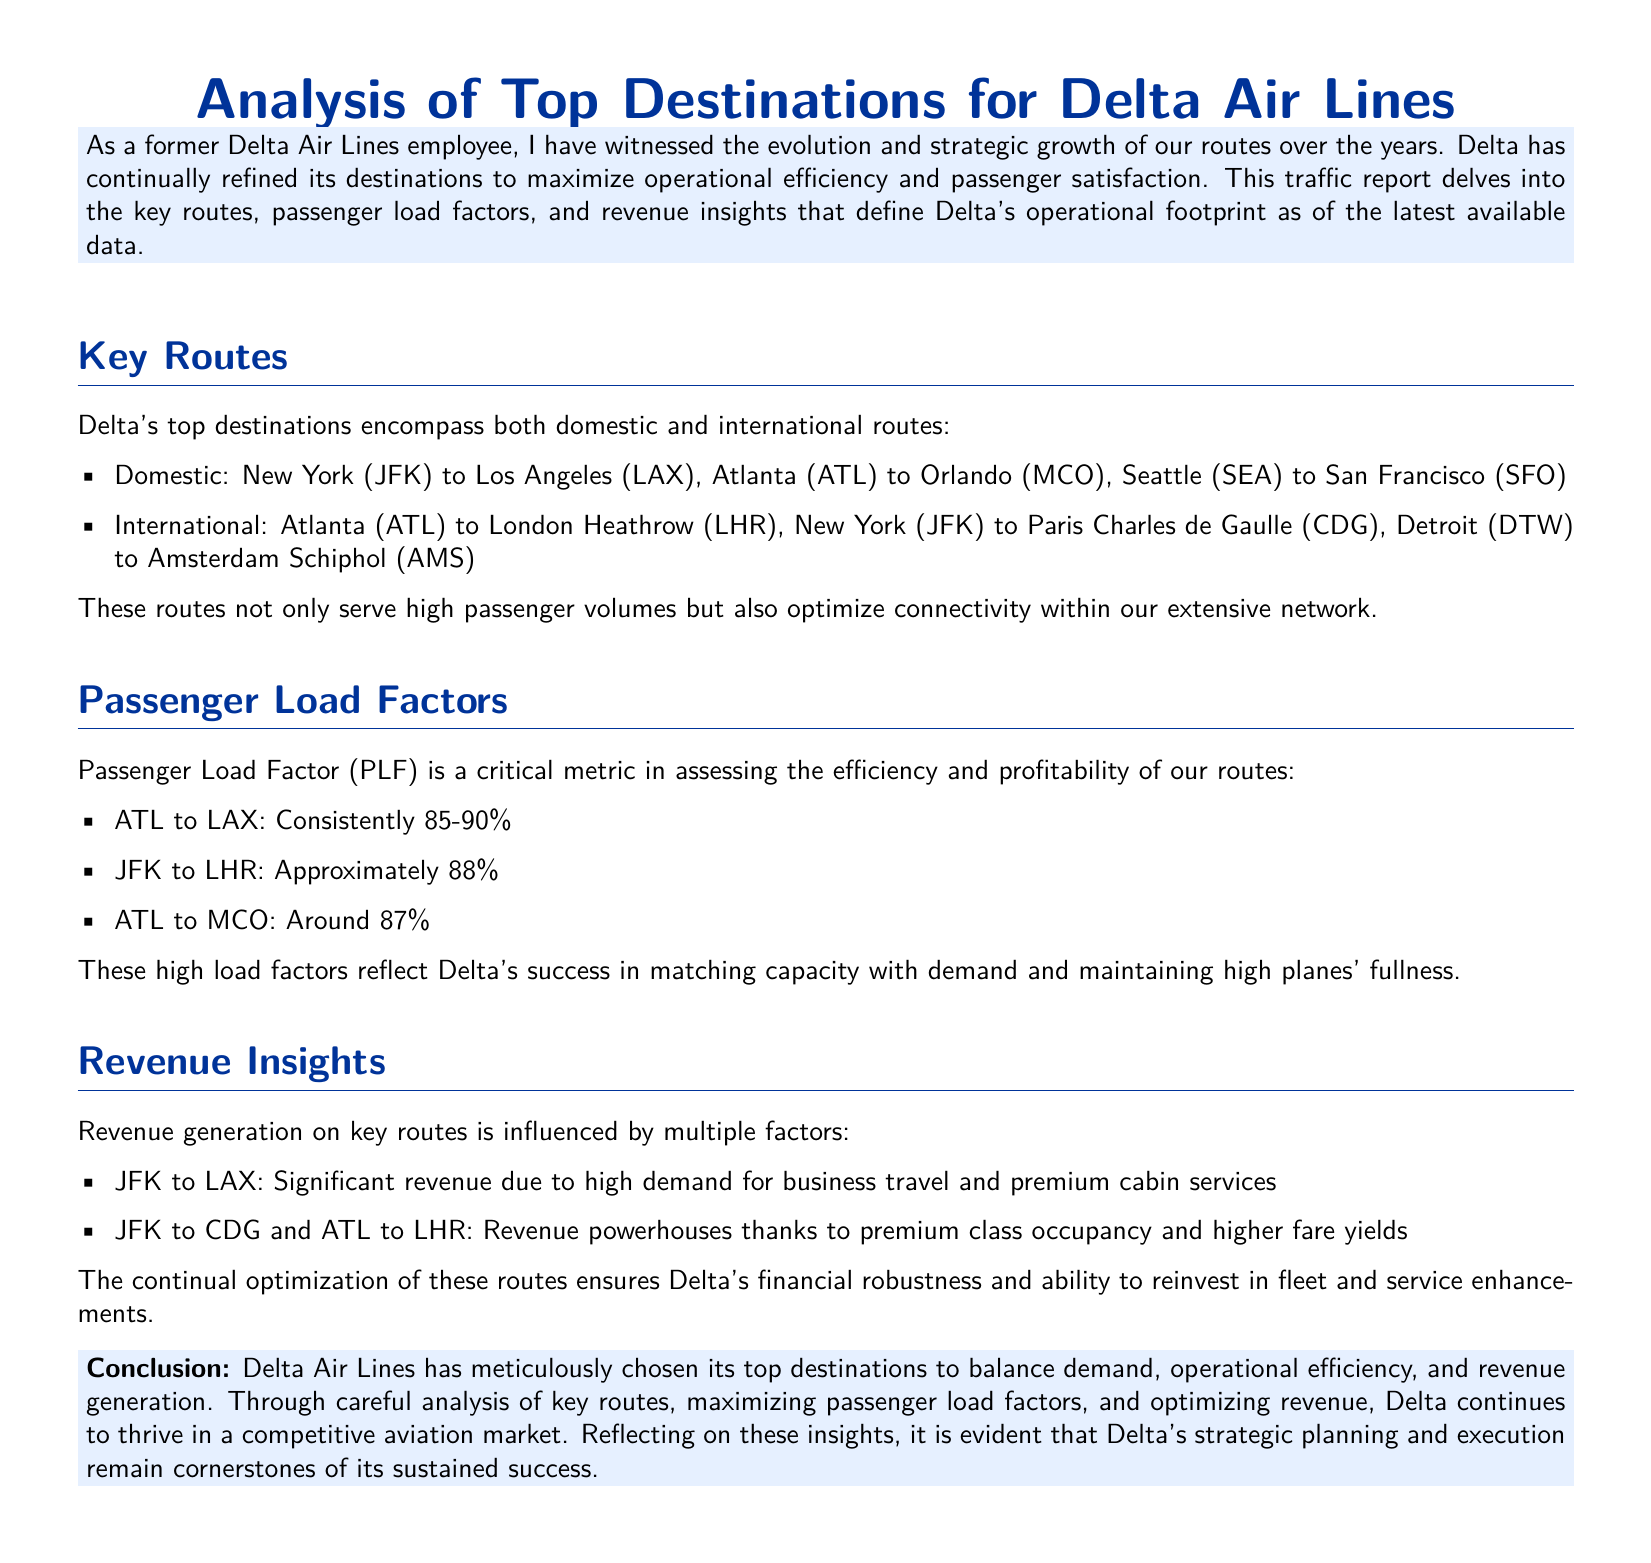what are Delta's top domestic destinations? The document lists Delta's domestic routes as New York (JFK) to Los Angeles (LAX), Atlanta (ATL) to Orlando (MCO), and Seattle (SEA) to San Francisco (SFO).
Answer: New York (JFK) to Los Angeles (LAX), Atlanta (ATL) to Orlando (MCO), Seattle (SEA) to San Francisco (SFO) what is the Passenger Load Factor for ATL to LAX? The document states that the Passenger Load Factor for ATL to LAX is consistently between 85-90%.
Answer: 85-90% which international route has a Passenger Load Factor of approximately 88%? The international route between New York (JFK) and London Heathrow (LHR) has a PLF of approximately 88%.
Answer: New York (JFK) to London Heathrow (LHR) what revenue factors influence the JFK to LAX route? The document mentions significant revenue due to high demand for business travel and premium cabin services for the JFK to LAX route.
Answer: High demand for business travel and premium cabin services what is a key metric for assessing route efficiency in Delta Air Lines? The Passenger Load Factor (PLF) is highlighted as a critical metric for assessing the efficiency and profitability of routes.
Answer: Passenger Load Factor (PLF) what indicates Delta's financial robustness? The continual optimization of high-revenue routes such as JFK to CDG and ATL to LHR indicates Delta's financial robustness.
Answer: Continual optimization of high-revenue routes which destinations are considered revenue powerhouses according to the report? The report identifies JFK to CDG and ATL to LHR as revenue powerhouses due to premium class occupancy and higher fare yields.
Answer: JFK to CDG and ATL to LHR what is the main focus of the traffic report? The traffic report focuses on analyzing key routes, passenger load factors, and revenue insights that define Delta's operational footprint.
Answer: Analyzing key routes, passenger load factors, and revenue insights 